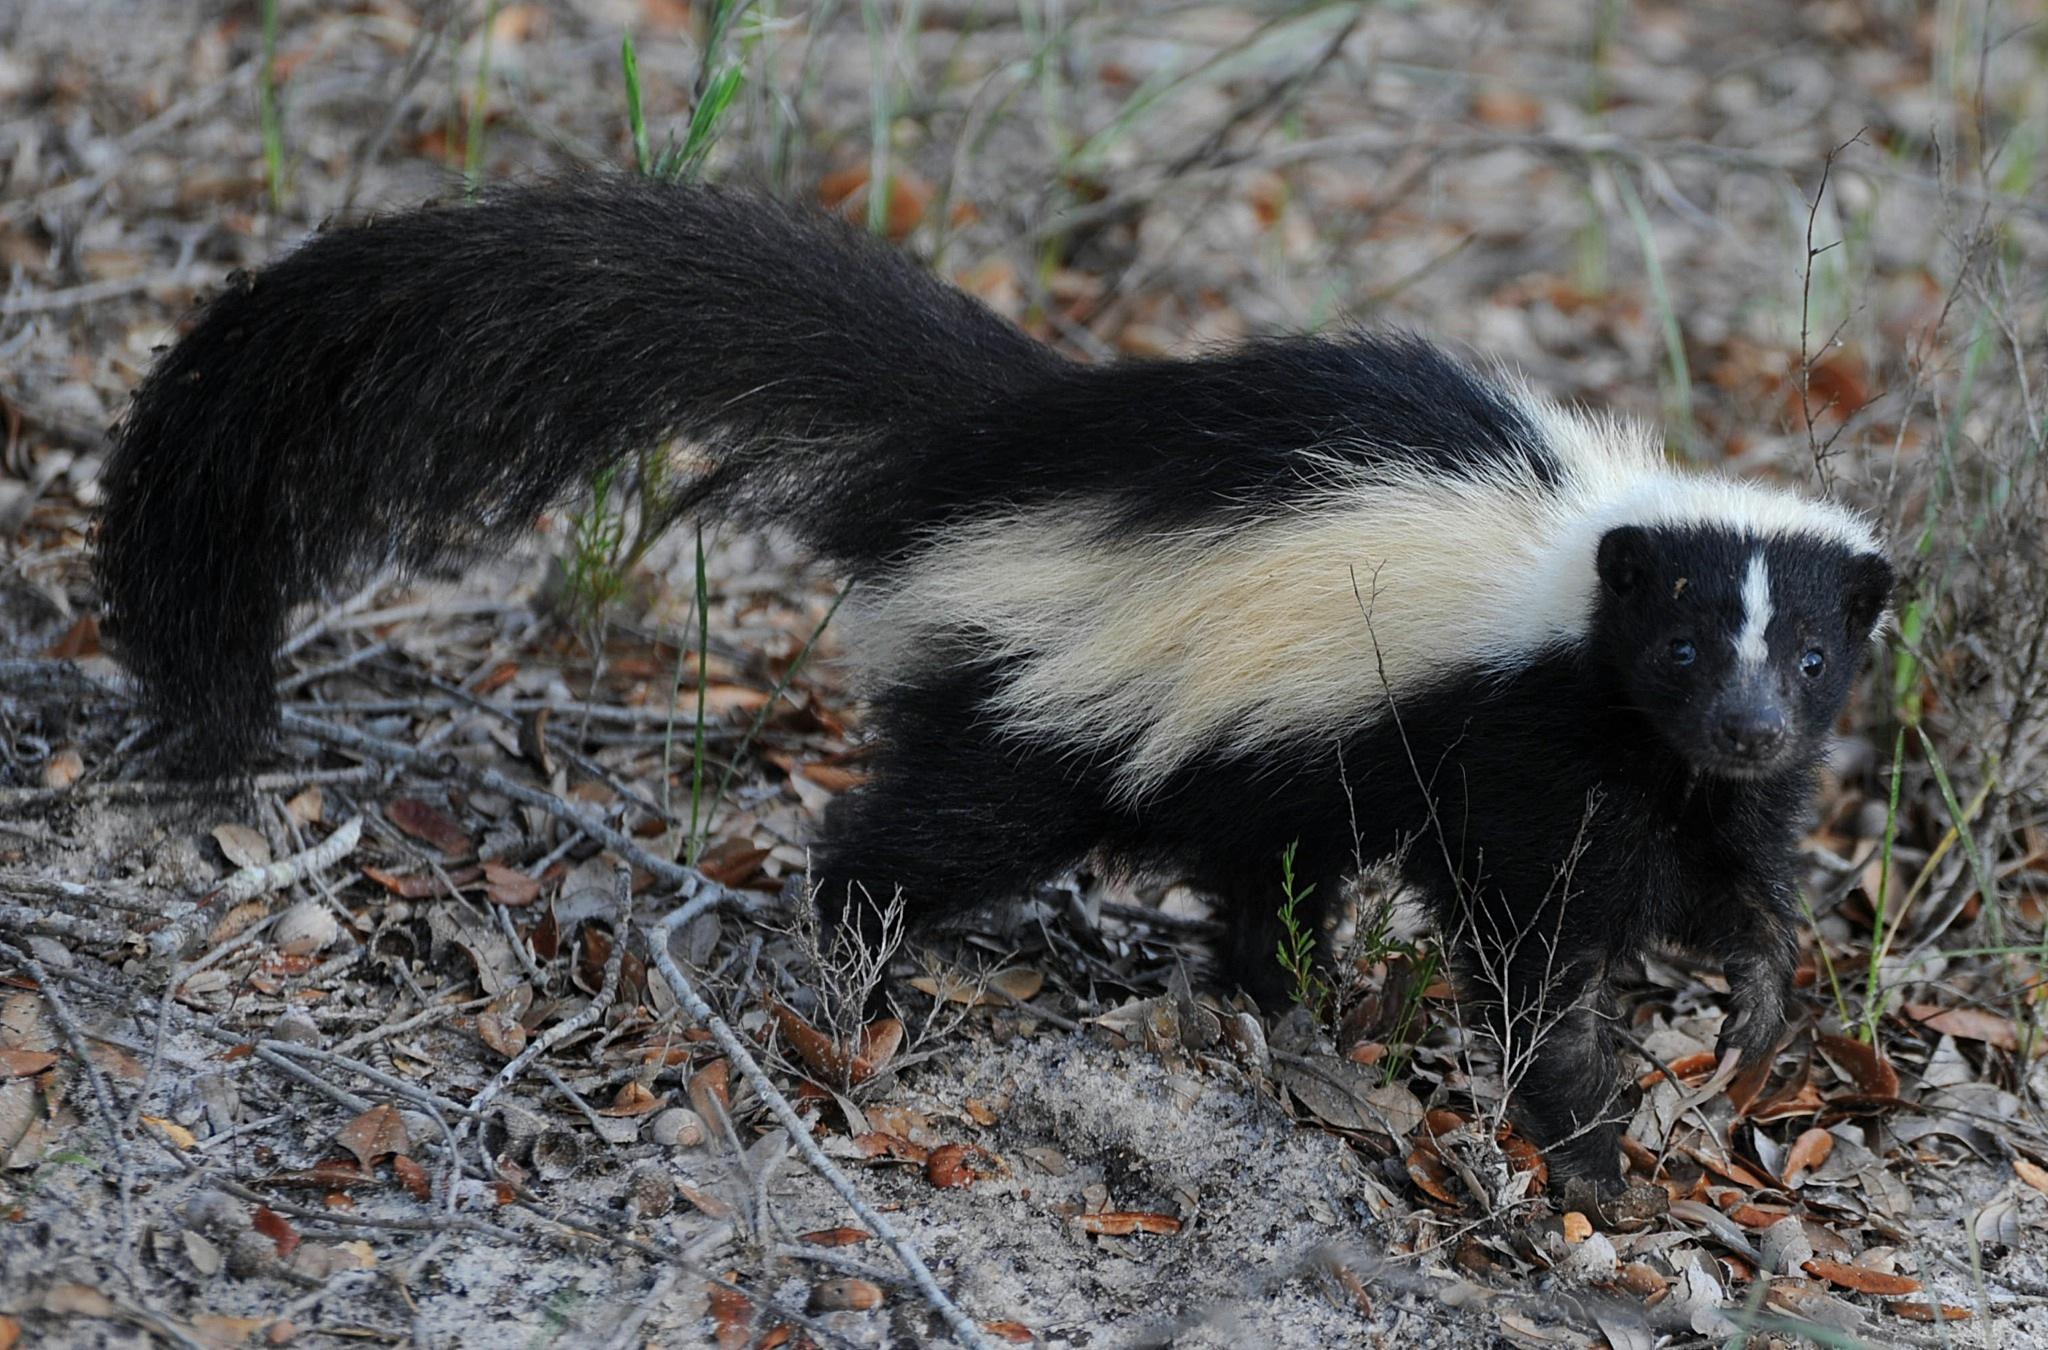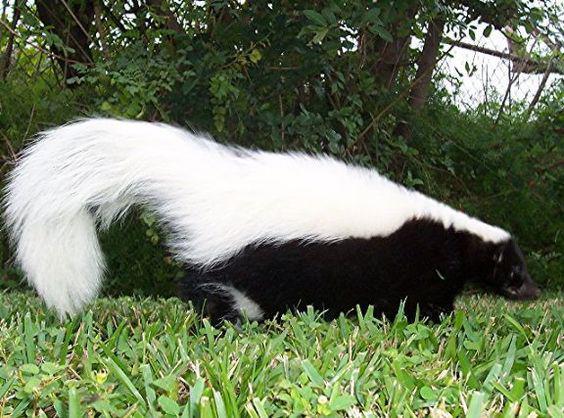The first image is the image on the left, the second image is the image on the right. Analyze the images presented: Is the assertion "There are two skunks that are positioned in a similar direction." valid? Answer yes or no. Yes. The first image is the image on the left, the second image is the image on the right. Evaluate the accuracy of this statement regarding the images: "Each image contains exactly one skunk, which is on all fours with its body turned rightward.". Is it true? Answer yes or no. Yes. 